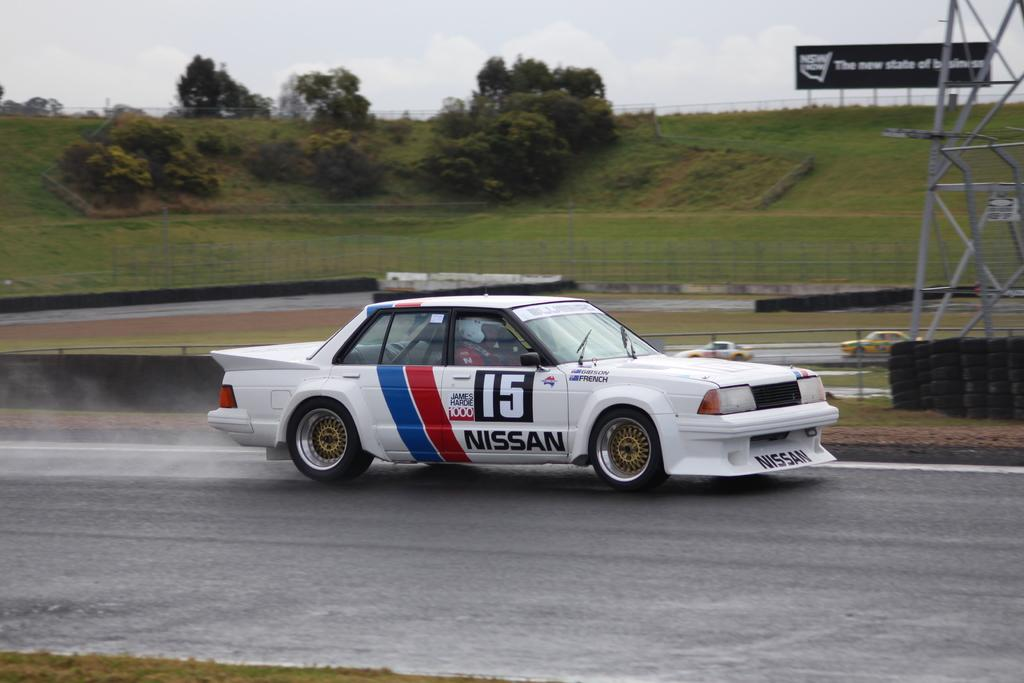What is the main subject of the image? There is a car on the road in the image. What can be seen in the background of the image? There is a fence, a tower, and trees in the background of the image. What other object is present in the image? There is a hoarding in the image. What is the authority's stance on the club's recent rate increase in the image? There is no mention of an authority, a club, or a rate increase in the image. 